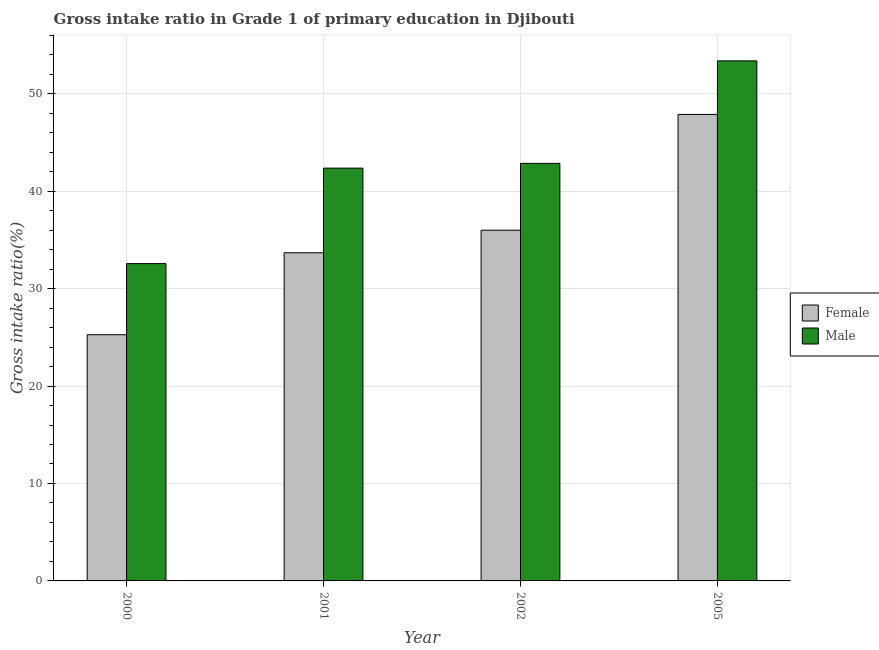How many groups of bars are there?
Ensure brevity in your answer.  4. What is the label of the 2nd group of bars from the left?
Your response must be concise. 2001. In how many cases, is the number of bars for a given year not equal to the number of legend labels?
Make the answer very short. 0. What is the gross intake ratio(female) in 2002?
Offer a very short reply. 35.99. Across all years, what is the maximum gross intake ratio(male)?
Your answer should be compact. 53.37. Across all years, what is the minimum gross intake ratio(female)?
Your response must be concise. 25.26. What is the total gross intake ratio(female) in the graph?
Offer a very short reply. 142.8. What is the difference between the gross intake ratio(male) in 2001 and that in 2005?
Give a very brief answer. -11.01. What is the difference between the gross intake ratio(male) in 2005 and the gross intake ratio(female) in 2002?
Provide a short and direct response. 10.52. What is the average gross intake ratio(male) per year?
Offer a very short reply. 42.78. In the year 2002, what is the difference between the gross intake ratio(female) and gross intake ratio(male)?
Offer a terse response. 0. In how many years, is the gross intake ratio(male) greater than 20 %?
Make the answer very short. 4. What is the ratio of the gross intake ratio(female) in 2001 to that in 2005?
Provide a succinct answer. 0.7. Is the gross intake ratio(male) in 2000 less than that in 2001?
Your response must be concise. Yes. What is the difference between the highest and the second highest gross intake ratio(male)?
Keep it short and to the point. 10.52. What is the difference between the highest and the lowest gross intake ratio(female)?
Your answer should be compact. 22.61. In how many years, is the gross intake ratio(male) greater than the average gross intake ratio(male) taken over all years?
Offer a very short reply. 2. How many years are there in the graph?
Make the answer very short. 4. What is the difference between two consecutive major ticks on the Y-axis?
Your answer should be compact. 10. Are the values on the major ticks of Y-axis written in scientific E-notation?
Ensure brevity in your answer.  No. Does the graph contain grids?
Your response must be concise. Yes. Where does the legend appear in the graph?
Offer a terse response. Center right. How many legend labels are there?
Offer a terse response. 2. How are the legend labels stacked?
Offer a terse response. Vertical. What is the title of the graph?
Keep it short and to the point. Gross intake ratio in Grade 1 of primary education in Djibouti. What is the label or title of the X-axis?
Make the answer very short. Year. What is the label or title of the Y-axis?
Make the answer very short. Gross intake ratio(%). What is the Gross intake ratio(%) in Female in 2000?
Keep it short and to the point. 25.26. What is the Gross intake ratio(%) of Male in 2000?
Make the answer very short. 32.56. What is the Gross intake ratio(%) in Female in 2001?
Your answer should be compact. 33.68. What is the Gross intake ratio(%) of Male in 2001?
Provide a short and direct response. 42.36. What is the Gross intake ratio(%) of Female in 2002?
Provide a succinct answer. 35.99. What is the Gross intake ratio(%) of Male in 2002?
Provide a succinct answer. 42.85. What is the Gross intake ratio(%) in Female in 2005?
Give a very brief answer. 47.87. What is the Gross intake ratio(%) of Male in 2005?
Your answer should be very brief. 53.37. Across all years, what is the maximum Gross intake ratio(%) of Female?
Give a very brief answer. 47.87. Across all years, what is the maximum Gross intake ratio(%) of Male?
Give a very brief answer. 53.37. Across all years, what is the minimum Gross intake ratio(%) in Female?
Provide a short and direct response. 25.26. Across all years, what is the minimum Gross intake ratio(%) in Male?
Make the answer very short. 32.56. What is the total Gross intake ratio(%) in Female in the graph?
Your answer should be very brief. 142.8. What is the total Gross intake ratio(%) of Male in the graph?
Offer a very short reply. 171.14. What is the difference between the Gross intake ratio(%) in Female in 2000 and that in 2001?
Offer a very short reply. -8.41. What is the difference between the Gross intake ratio(%) of Male in 2000 and that in 2001?
Make the answer very short. -9.8. What is the difference between the Gross intake ratio(%) in Female in 2000 and that in 2002?
Keep it short and to the point. -10.73. What is the difference between the Gross intake ratio(%) in Male in 2000 and that in 2002?
Your response must be concise. -10.29. What is the difference between the Gross intake ratio(%) in Female in 2000 and that in 2005?
Ensure brevity in your answer.  -22.61. What is the difference between the Gross intake ratio(%) of Male in 2000 and that in 2005?
Make the answer very short. -20.81. What is the difference between the Gross intake ratio(%) in Female in 2001 and that in 2002?
Make the answer very short. -2.31. What is the difference between the Gross intake ratio(%) in Male in 2001 and that in 2002?
Give a very brief answer. -0.49. What is the difference between the Gross intake ratio(%) of Female in 2001 and that in 2005?
Your response must be concise. -14.2. What is the difference between the Gross intake ratio(%) in Male in 2001 and that in 2005?
Your response must be concise. -11.01. What is the difference between the Gross intake ratio(%) in Female in 2002 and that in 2005?
Provide a short and direct response. -11.88. What is the difference between the Gross intake ratio(%) in Male in 2002 and that in 2005?
Offer a terse response. -10.52. What is the difference between the Gross intake ratio(%) of Female in 2000 and the Gross intake ratio(%) of Male in 2001?
Give a very brief answer. -17.1. What is the difference between the Gross intake ratio(%) of Female in 2000 and the Gross intake ratio(%) of Male in 2002?
Ensure brevity in your answer.  -17.59. What is the difference between the Gross intake ratio(%) in Female in 2000 and the Gross intake ratio(%) in Male in 2005?
Keep it short and to the point. -28.1. What is the difference between the Gross intake ratio(%) in Female in 2001 and the Gross intake ratio(%) in Male in 2002?
Ensure brevity in your answer.  -9.17. What is the difference between the Gross intake ratio(%) in Female in 2001 and the Gross intake ratio(%) in Male in 2005?
Keep it short and to the point. -19.69. What is the difference between the Gross intake ratio(%) in Female in 2002 and the Gross intake ratio(%) in Male in 2005?
Provide a short and direct response. -17.38. What is the average Gross intake ratio(%) of Female per year?
Your response must be concise. 35.7. What is the average Gross intake ratio(%) in Male per year?
Your response must be concise. 42.78. In the year 2000, what is the difference between the Gross intake ratio(%) of Female and Gross intake ratio(%) of Male?
Keep it short and to the point. -7.3. In the year 2001, what is the difference between the Gross intake ratio(%) in Female and Gross intake ratio(%) in Male?
Provide a short and direct response. -8.68. In the year 2002, what is the difference between the Gross intake ratio(%) in Female and Gross intake ratio(%) in Male?
Offer a very short reply. -6.86. In the year 2005, what is the difference between the Gross intake ratio(%) in Female and Gross intake ratio(%) in Male?
Your response must be concise. -5.49. What is the ratio of the Gross intake ratio(%) in Female in 2000 to that in 2001?
Your answer should be very brief. 0.75. What is the ratio of the Gross intake ratio(%) of Male in 2000 to that in 2001?
Your response must be concise. 0.77. What is the ratio of the Gross intake ratio(%) of Female in 2000 to that in 2002?
Provide a succinct answer. 0.7. What is the ratio of the Gross intake ratio(%) of Male in 2000 to that in 2002?
Offer a terse response. 0.76. What is the ratio of the Gross intake ratio(%) of Female in 2000 to that in 2005?
Make the answer very short. 0.53. What is the ratio of the Gross intake ratio(%) in Male in 2000 to that in 2005?
Your answer should be very brief. 0.61. What is the ratio of the Gross intake ratio(%) in Female in 2001 to that in 2002?
Your response must be concise. 0.94. What is the ratio of the Gross intake ratio(%) in Male in 2001 to that in 2002?
Make the answer very short. 0.99. What is the ratio of the Gross intake ratio(%) of Female in 2001 to that in 2005?
Offer a terse response. 0.7. What is the ratio of the Gross intake ratio(%) in Male in 2001 to that in 2005?
Your answer should be very brief. 0.79. What is the ratio of the Gross intake ratio(%) of Female in 2002 to that in 2005?
Your answer should be compact. 0.75. What is the ratio of the Gross intake ratio(%) in Male in 2002 to that in 2005?
Your response must be concise. 0.8. What is the difference between the highest and the second highest Gross intake ratio(%) in Female?
Offer a terse response. 11.88. What is the difference between the highest and the second highest Gross intake ratio(%) in Male?
Offer a terse response. 10.52. What is the difference between the highest and the lowest Gross intake ratio(%) of Female?
Provide a short and direct response. 22.61. What is the difference between the highest and the lowest Gross intake ratio(%) of Male?
Ensure brevity in your answer.  20.81. 